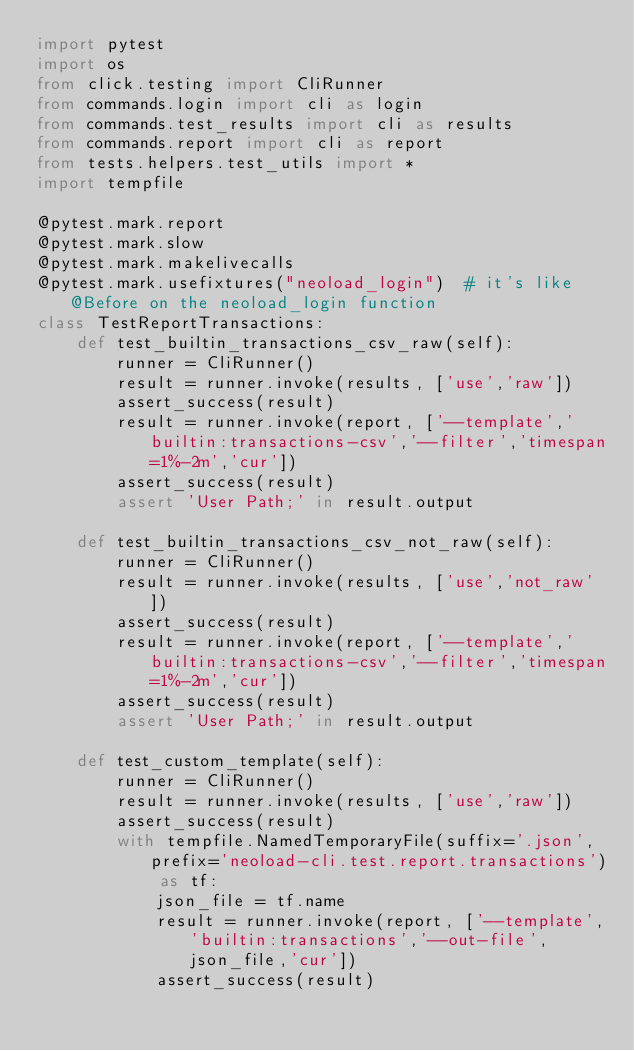<code> <loc_0><loc_0><loc_500><loc_500><_Python_>import pytest
import os
from click.testing import CliRunner
from commands.login import cli as login
from commands.test_results import cli as results
from commands.report import cli as report
from tests.helpers.test_utils import *
import tempfile

@pytest.mark.report
@pytest.mark.slow
@pytest.mark.makelivecalls
@pytest.mark.usefixtures("neoload_login")  # it's like @Before on the neoload_login function
class TestReportTransactions:
    def test_builtin_transactions_csv_raw(self):
        runner = CliRunner()
        result = runner.invoke(results, ['use','raw'])
        assert_success(result)
        result = runner.invoke(report, ['--template','builtin:transactions-csv','--filter','timespan=1%-2m','cur'])
        assert_success(result)
        assert 'User Path;' in result.output

    def test_builtin_transactions_csv_not_raw(self):
        runner = CliRunner()
        result = runner.invoke(results, ['use','not_raw'])
        assert_success(result)
        result = runner.invoke(report, ['--template','builtin:transactions-csv','--filter','timespan=1%-2m','cur'])
        assert_success(result)
        assert 'User Path;' in result.output

    def test_custom_template(self):
        runner = CliRunner()
        result = runner.invoke(results, ['use','raw'])
        assert_success(result)
        with tempfile.NamedTemporaryFile(suffix='.json', prefix='neoload-cli.test.report.transactions') as tf:
            json_file = tf.name
            result = runner.invoke(report, ['--template','builtin:transactions','--out-file',json_file,'cur'])
            assert_success(result)</code> 